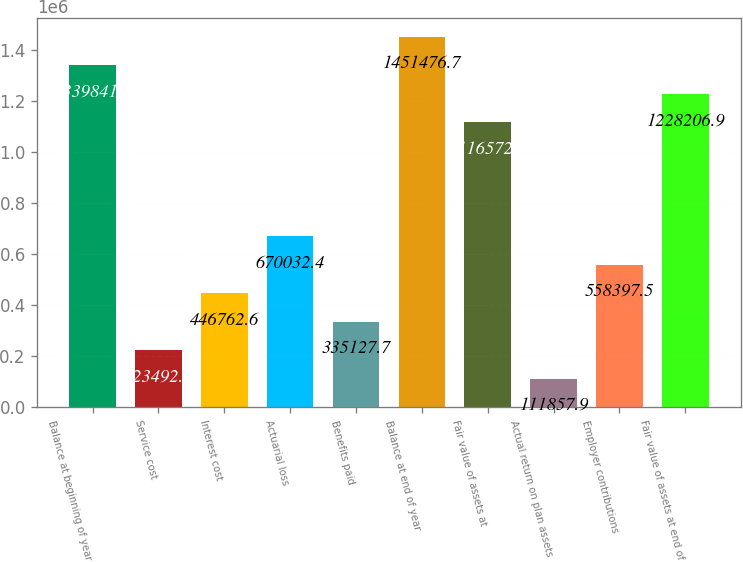Convert chart. <chart><loc_0><loc_0><loc_500><loc_500><bar_chart><fcel>Balance at beginning of year<fcel>Service cost<fcel>Interest cost<fcel>Actuarial loss<fcel>Benefits paid<fcel>Balance at end of year<fcel>Fair value of assets at<fcel>Actual return on plan assets<fcel>Employer contributions<fcel>Fair value of assets at end of<nl><fcel>1.33984e+06<fcel>223493<fcel>446763<fcel>670032<fcel>335128<fcel>1.45148e+06<fcel>1.11657e+06<fcel>111858<fcel>558398<fcel>1.22821e+06<nl></chart> 